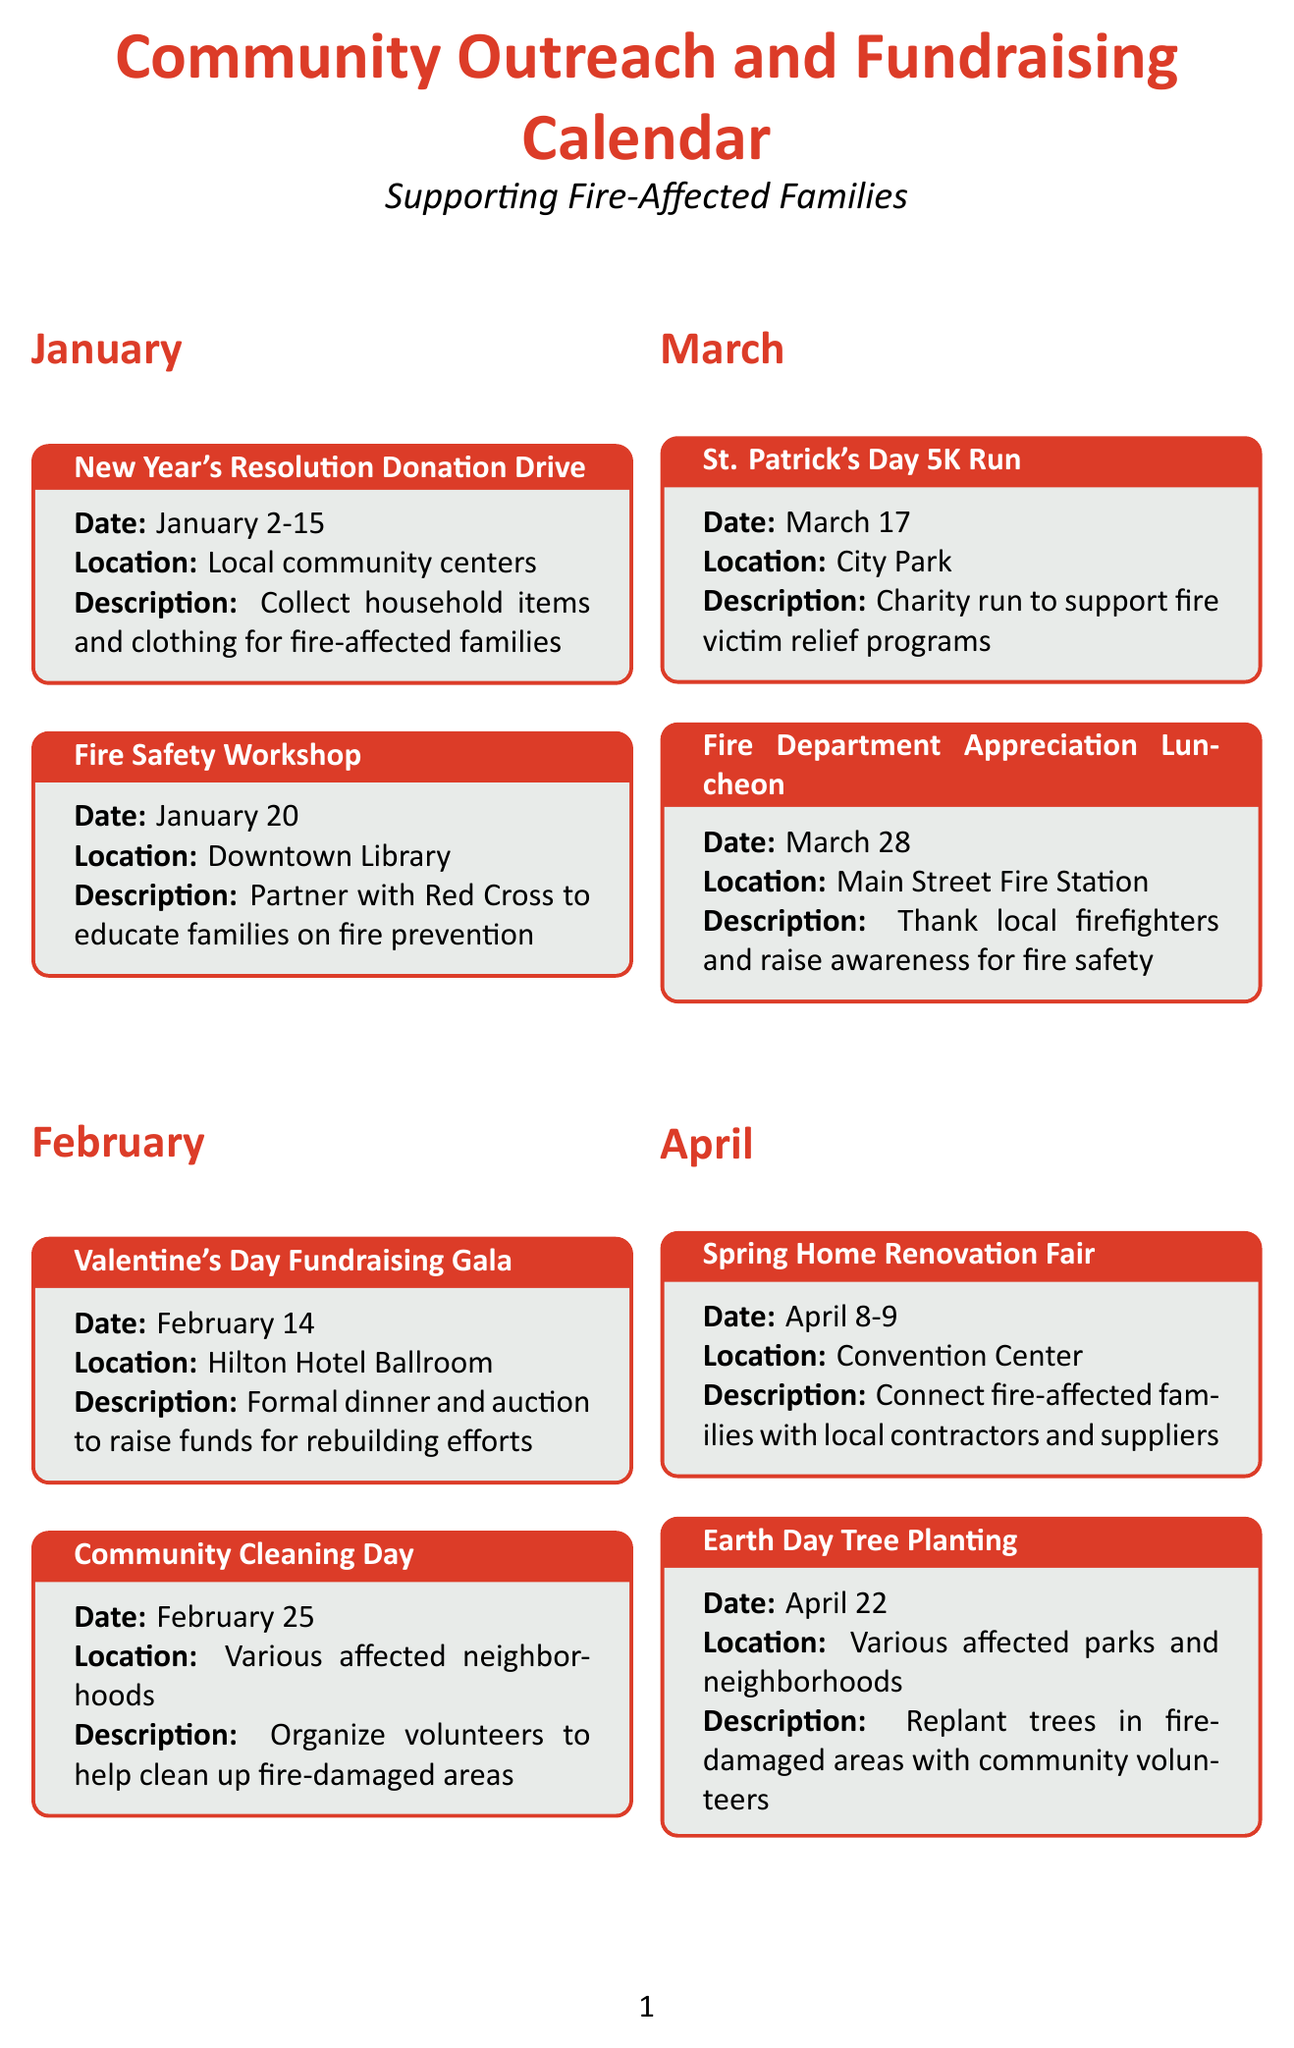What event is scheduled for January 20? The event on January 20 is a Fire Safety Workshop.
Answer: Fire Safety Workshop What is the date of the Valentine's Day Fundraising Gala? The Valentine's Day Fundraising Gala is on February 14.
Answer: February 14 How many events are planned for December? There are three events planned for December as listed in the document.
Answer: 3 Which location hosts the Thanksgiving Food Basket Distribution? The Thanksgiving Food Basket Distribution takes place at the Food Bank warehouse.
Answer: Food Bank warehouse What type of event is organized on March 17? The event on March 17 is a charity run to support fire victim relief programs.
Answer: Charity run What is the main purpose of the Mother's Day Brunch Fundraiser? The main purpose is to support single mothers affected by fires.
Answer: Support single mothers Which month features a Community Potluck and Resource Fair? The Community Potluck and Resource Fair is in August.
Answer: August On what date does the Halloween Costume Drive start? The Halloween Costume Drive starts on October 1.
Answer: October 1 How often do the National Preparedness Month Workshops occur in September? These workshops are held every Saturday in September.
Answer: Every Saturday in September 